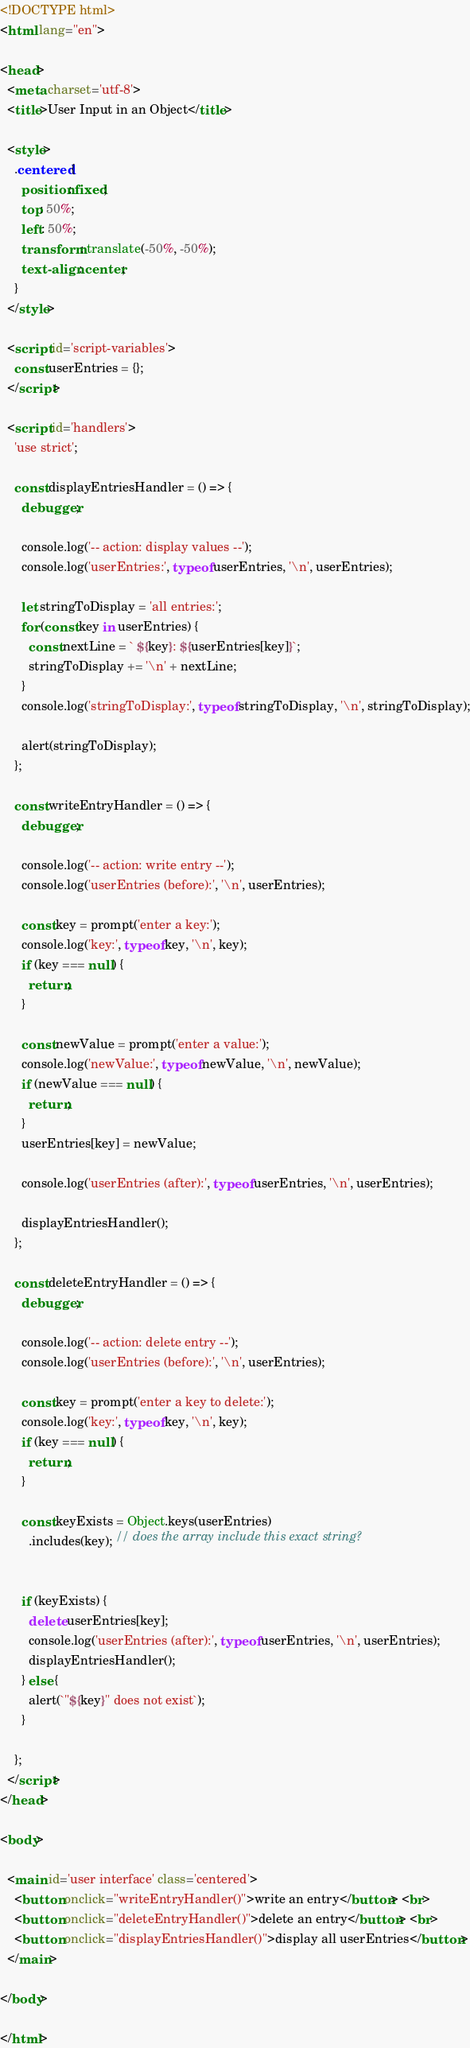Convert code to text. <code><loc_0><loc_0><loc_500><loc_500><_HTML_><!DOCTYPE html>
<html lang="en">

<head>
  <meta charset='utf-8'>
  <title>User Input in an Object</title>

  <style>
    .centered {
      position: fixed;
      top: 50%;
      left: 50%;
      transform: translate(-50%, -50%);
      text-align: center;
    }
  </style>

  <script id='script-variables'>
    const userEntries = {};
  </script>

  <script id='handlers'>
    'use strict';

    const displayEntriesHandler = () => {
      debugger;

      console.log('-- action: display values --');
      console.log('userEntries:', typeof userEntries, '\n', userEntries);

      let stringToDisplay = 'all entries:';
      for (const key in userEntries) {
        const nextLine = ` ${key}: ${userEntries[key]}`;
        stringToDisplay += '\n' + nextLine;
      }
      console.log('stringToDisplay:', typeof stringToDisplay, '\n', stringToDisplay);

      alert(stringToDisplay);
    };

    const writeEntryHandler = () => {
      debugger;

      console.log('-- action: write entry --');
      console.log('userEntries (before):', '\n', userEntries);

      const key = prompt('enter a key:');
      console.log('key:', typeof key, '\n', key);
      if (key === null) {
        return;
      }

      const newValue = prompt('enter a value:');
      console.log('newValue:', typeof newValue, '\n', newValue);
      if (newValue === null) {
        return;
      }
      userEntries[key] = newValue;

      console.log('userEntries (after):', typeof userEntries, '\n', userEntries);

      displayEntriesHandler();
    };

    const deleteEntryHandler = () => {
      debugger;

      console.log('-- action: delete entry --');
      console.log('userEntries (before):', '\n', userEntries);

      const key = prompt('enter a key to delete:');
      console.log('key:', typeof key, '\n', key);
      if (key === null) {
        return;
      }

      const keyExists = Object.keys(userEntries)
        .includes(key); // does the array include this exact string?


      if (keyExists) {
        delete userEntries[key];
        console.log('userEntries (after):', typeof userEntries, '\n', userEntries);
        displayEntriesHandler();
      } else {
        alert(`"${key}" does not exist`);
      }

    };
  </script>
</head>

<body>

  <main id='user interface' class='centered'>
    <button onclick="writeEntryHandler()">write an entry</button> <br>
    <button onclick="deleteEntryHandler()">delete an entry</button> <br>
    <button onclick="displayEntriesHandler()">display all userEntries</button>
  </main>

</body>

</html>
</code> 